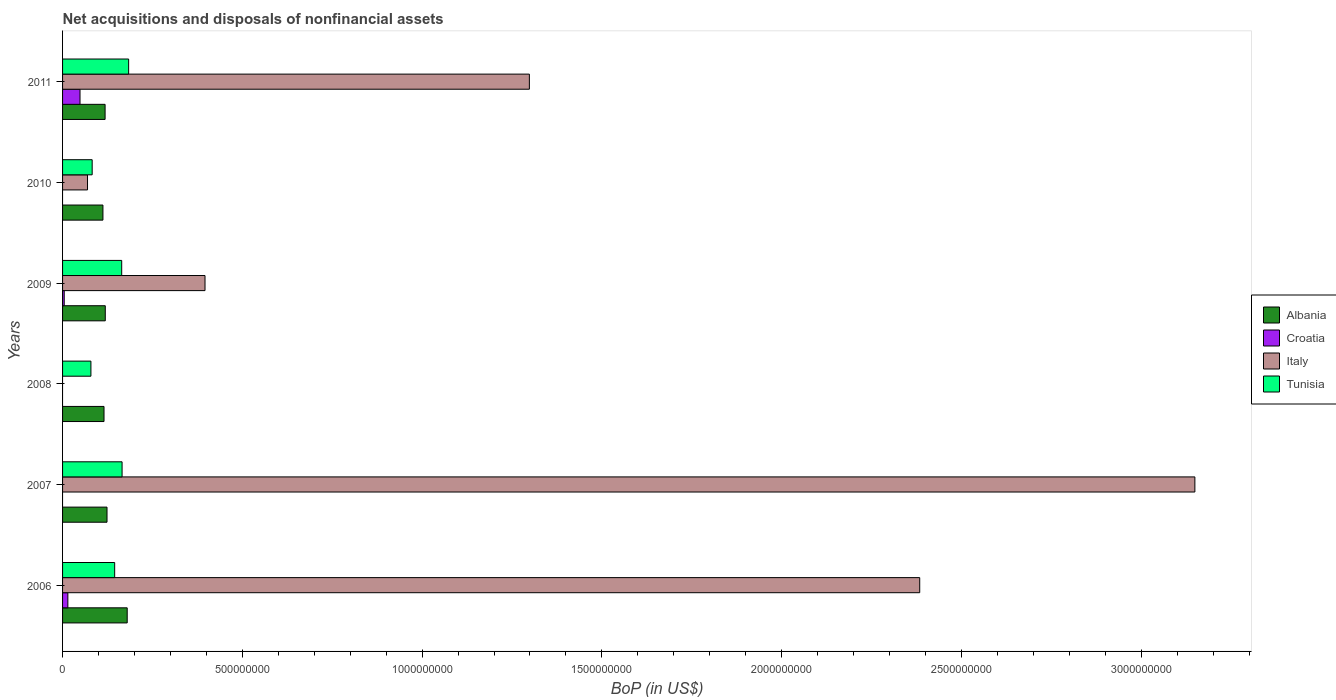How many groups of bars are there?
Provide a short and direct response. 6. How many bars are there on the 1st tick from the bottom?
Offer a terse response. 4. What is the label of the 6th group of bars from the top?
Provide a succinct answer. 2006. What is the Balance of Payments in Albania in 2008?
Your answer should be compact. 1.15e+08. Across all years, what is the maximum Balance of Payments in Albania?
Your answer should be very brief. 1.80e+08. What is the total Balance of Payments in Tunisia in the graph?
Ensure brevity in your answer.  8.20e+08. What is the difference between the Balance of Payments in Italy in 2007 and that in 2009?
Offer a very short reply. 2.75e+09. What is the difference between the Balance of Payments in Italy in 2006 and the Balance of Payments in Albania in 2007?
Your response must be concise. 2.26e+09. What is the average Balance of Payments in Croatia per year?
Provide a succinct answer. 1.13e+07. In the year 2009, what is the difference between the Balance of Payments in Croatia and Balance of Payments in Albania?
Give a very brief answer. -1.14e+08. What is the ratio of the Balance of Payments in Tunisia in 2007 to that in 2010?
Your response must be concise. 2.01. Is the difference between the Balance of Payments in Croatia in 2006 and 2009 greater than the difference between the Balance of Payments in Albania in 2006 and 2009?
Ensure brevity in your answer.  No. What is the difference between the highest and the second highest Balance of Payments in Albania?
Your answer should be compact. 5.62e+07. What is the difference between the highest and the lowest Balance of Payments in Italy?
Your answer should be compact. 3.15e+09. In how many years, is the Balance of Payments in Albania greater than the average Balance of Payments in Albania taken over all years?
Ensure brevity in your answer.  1. How many bars are there?
Give a very brief answer. 20. Are all the bars in the graph horizontal?
Offer a very short reply. Yes. Are the values on the major ticks of X-axis written in scientific E-notation?
Make the answer very short. No. Does the graph contain grids?
Your answer should be very brief. No. Where does the legend appear in the graph?
Your response must be concise. Center right. How many legend labels are there?
Make the answer very short. 4. How are the legend labels stacked?
Your answer should be very brief. Vertical. What is the title of the graph?
Make the answer very short. Net acquisitions and disposals of nonfinancial assets. Does "Latvia" appear as one of the legend labels in the graph?
Keep it short and to the point. No. What is the label or title of the X-axis?
Make the answer very short. BoP (in US$). What is the BoP (in US$) in Albania in 2006?
Give a very brief answer. 1.80e+08. What is the BoP (in US$) of Croatia in 2006?
Give a very brief answer. 1.47e+07. What is the BoP (in US$) of Italy in 2006?
Your response must be concise. 2.38e+09. What is the BoP (in US$) of Tunisia in 2006?
Your answer should be very brief. 1.45e+08. What is the BoP (in US$) in Albania in 2007?
Your answer should be compact. 1.24e+08. What is the BoP (in US$) of Italy in 2007?
Your answer should be compact. 3.15e+09. What is the BoP (in US$) in Tunisia in 2007?
Offer a very short reply. 1.66e+08. What is the BoP (in US$) of Albania in 2008?
Your answer should be compact. 1.15e+08. What is the BoP (in US$) in Croatia in 2008?
Make the answer very short. 0. What is the BoP (in US$) in Tunisia in 2008?
Give a very brief answer. 7.89e+07. What is the BoP (in US$) in Albania in 2009?
Make the answer very short. 1.19e+08. What is the BoP (in US$) of Croatia in 2009?
Your answer should be very brief. 4.61e+06. What is the BoP (in US$) in Italy in 2009?
Your response must be concise. 3.96e+08. What is the BoP (in US$) of Tunisia in 2009?
Offer a very short reply. 1.64e+08. What is the BoP (in US$) of Albania in 2010?
Ensure brevity in your answer.  1.12e+08. What is the BoP (in US$) in Croatia in 2010?
Offer a terse response. 0. What is the BoP (in US$) in Italy in 2010?
Ensure brevity in your answer.  6.94e+07. What is the BoP (in US$) in Tunisia in 2010?
Ensure brevity in your answer.  8.24e+07. What is the BoP (in US$) of Albania in 2011?
Your answer should be compact. 1.18e+08. What is the BoP (in US$) in Croatia in 2011?
Your response must be concise. 4.85e+07. What is the BoP (in US$) in Italy in 2011?
Make the answer very short. 1.30e+09. What is the BoP (in US$) of Tunisia in 2011?
Offer a terse response. 1.84e+08. Across all years, what is the maximum BoP (in US$) of Albania?
Provide a succinct answer. 1.80e+08. Across all years, what is the maximum BoP (in US$) of Croatia?
Give a very brief answer. 4.85e+07. Across all years, what is the maximum BoP (in US$) in Italy?
Provide a succinct answer. 3.15e+09. Across all years, what is the maximum BoP (in US$) in Tunisia?
Ensure brevity in your answer.  1.84e+08. Across all years, what is the minimum BoP (in US$) in Albania?
Provide a short and direct response. 1.12e+08. Across all years, what is the minimum BoP (in US$) in Croatia?
Give a very brief answer. 0. Across all years, what is the minimum BoP (in US$) in Italy?
Make the answer very short. 0. Across all years, what is the minimum BoP (in US$) in Tunisia?
Your response must be concise. 7.89e+07. What is the total BoP (in US$) in Albania in the graph?
Provide a short and direct response. 7.68e+08. What is the total BoP (in US$) of Croatia in the graph?
Your answer should be compact. 6.79e+07. What is the total BoP (in US$) in Italy in the graph?
Give a very brief answer. 7.30e+09. What is the total BoP (in US$) of Tunisia in the graph?
Keep it short and to the point. 8.20e+08. What is the difference between the BoP (in US$) of Albania in 2006 and that in 2007?
Offer a terse response. 5.62e+07. What is the difference between the BoP (in US$) of Italy in 2006 and that in 2007?
Ensure brevity in your answer.  -7.65e+08. What is the difference between the BoP (in US$) of Tunisia in 2006 and that in 2007?
Your response must be concise. -2.06e+07. What is the difference between the BoP (in US$) in Albania in 2006 and that in 2008?
Your answer should be compact. 6.45e+07. What is the difference between the BoP (in US$) in Tunisia in 2006 and that in 2008?
Provide a succinct answer. 6.60e+07. What is the difference between the BoP (in US$) of Albania in 2006 and that in 2009?
Make the answer very short. 6.10e+07. What is the difference between the BoP (in US$) in Croatia in 2006 and that in 2009?
Your answer should be compact. 1.01e+07. What is the difference between the BoP (in US$) in Italy in 2006 and that in 2009?
Your answer should be compact. 1.99e+09. What is the difference between the BoP (in US$) in Tunisia in 2006 and that in 2009?
Offer a terse response. -1.96e+07. What is the difference between the BoP (in US$) of Albania in 2006 and that in 2010?
Provide a short and direct response. 6.75e+07. What is the difference between the BoP (in US$) in Italy in 2006 and that in 2010?
Make the answer very short. 2.31e+09. What is the difference between the BoP (in US$) of Tunisia in 2006 and that in 2010?
Your answer should be very brief. 6.26e+07. What is the difference between the BoP (in US$) in Albania in 2006 and that in 2011?
Offer a terse response. 6.15e+07. What is the difference between the BoP (in US$) of Croatia in 2006 and that in 2011?
Provide a short and direct response. -3.38e+07. What is the difference between the BoP (in US$) in Italy in 2006 and that in 2011?
Make the answer very short. 1.09e+09. What is the difference between the BoP (in US$) of Tunisia in 2006 and that in 2011?
Provide a short and direct response. -3.88e+07. What is the difference between the BoP (in US$) in Albania in 2007 and that in 2008?
Provide a succinct answer. 8.34e+06. What is the difference between the BoP (in US$) in Tunisia in 2007 and that in 2008?
Give a very brief answer. 8.66e+07. What is the difference between the BoP (in US$) of Albania in 2007 and that in 2009?
Your response must be concise. 4.84e+06. What is the difference between the BoP (in US$) of Italy in 2007 and that in 2009?
Give a very brief answer. 2.75e+09. What is the difference between the BoP (in US$) of Tunisia in 2007 and that in 2009?
Provide a succinct answer. 1.04e+06. What is the difference between the BoP (in US$) of Albania in 2007 and that in 2010?
Keep it short and to the point. 1.14e+07. What is the difference between the BoP (in US$) in Italy in 2007 and that in 2010?
Your answer should be very brief. 3.08e+09. What is the difference between the BoP (in US$) in Tunisia in 2007 and that in 2010?
Give a very brief answer. 8.32e+07. What is the difference between the BoP (in US$) of Albania in 2007 and that in 2011?
Make the answer very short. 5.35e+06. What is the difference between the BoP (in US$) of Italy in 2007 and that in 2011?
Give a very brief answer. 1.85e+09. What is the difference between the BoP (in US$) of Tunisia in 2007 and that in 2011?
Keep it short and to the point. -1.82e+07. What is the difference between the BoP (in US$) in Albania in 2008 and that in 2009?
Give a very brief answer. -3.50e+06. What is the difference between the BoP (in US$) of Tunisia in 2008 and that in 2009?
Make the answer very short. -8.56e+07. What is the difference between the BoP (in US$) in Albania in 2008 and that in 2010?
Give a very brief answer. 3.03e+06. What is the difference between the BoP (in US$) of Tunisia in 2008 and that in 2010?
Provide a succinct answer. -3.48e+06. What is the difference between the BoP (in US$) of Albania in 2008 and that in 2011?
Offer a terse response. -2.99e+06. What is the difference between the BoP (in US$) in Tunisia in 2008 and that in 2011?
Offer a terse response. -1.05e+08. What is the difference between the BoP (in US$) in Albania in 2009 and that in 2010?
Offer a very short reply. 6.53e+06. What is the difference between the BoP (in US$) of Italy in 2009 and that in 2010?
Provide a succinct answer. 3.27e+08. What is the difference between the BoP (in US$) in Tunisia in 2009 and that in 2010?
Offer a very short reply. 8.21e+07. What is the difference between the BoP (in US$) of Albania in 2009 and that in 2011?
Give a very brief answer. 5.13e+05. What is the difference between the BoP (in US$) in Croatia in 2009 and that in 2011?
Your answer should be compact. -4.39e+07. What is the difference between the BoP (in US$) of Italy in 2009 and that in 2011?
Offer a terse response. -9.02e+08. What is the difference between the BoP (in US$) of Tunisia in 2009 and that in 2011?
Provide a succinct answer. -1.93e+07. What is the difference between the BoP (in US$) in Albania in 2010 and that in 2011?
Provide a succinct answer. -6.02e+06. What is the difference between the BoP (in US$) in Italy in 2010 and that in 2011?
Your answer should be very brief. -1.23e+09. What is the difference between the BoP (in US$) in Tunisia in 2010 and that in 2011?
Make the answer very short. -1.01e+08. What is the difference between the BoP (in US$) in Albania in 2006 and the BoP (in US$) in Italy in 2007?
Keep it short and to the point. -2.97e+09. What is the difference between the BoP (in US$) of Albania in 2006 and the BoP (in US$) of Tunisia in 2007?
Make the answer very short. 1.43e+07. What is the difference between the BoP (in US$) of Croatia in 2006 and the BoP (in US$) of Italy in 2007?
Provide a short and direct response. -3.13e+09. What is the difference between the BoP (in US$) in Croatia in 2006 and the BoP (in US$) in Tunisia in 2007?
Ensure brevity in your answer.  -1.51e+08. What is the difference between the BoP (in US$) in Italy in 2006 and the BoP (in US$) in Tunisia in 2007?
Provide a succinct answer. 2.22e+09. What is the difference between the BoP (in US$) in Albania in 2006 and the BoP (in US$) in Tunisia in 2008?
Give a very brief answer. 1.01e+08. What is the difference between the BoP (in US$) of Croatia in 2006 and the BoP (in US$) of Tunisia in 2008?
Give a very brief answer. -6.42e+07. What is the difference between the BoP (in US$) of Italy in 2006 and the BoP (in US$) of Tunisia in 2008?
Offer a terse response. 2.31e+09. What is the difference between the BoP (in US$) in Albania in 2006 and the BoP (in US$) in Croatia in 2009?
Your answer should be very brief. 1.75e+08. What is the difference between the BoP (in US$) of Albania in 2006 and the BoP (in US$) of Italy in 2009?
Provide a succinct answer. -2.16e+08. What is the difference between the BoP (in US$) of Albania in 2006 and the BoP (in US$) of Tunisia in 2009?
Your answer should be compact. 1.53e+07. What is the difference between the BoP (in US$) of Croatia in 2006 and the BoP (in US$) of Italy in 2009?
Offer a very short reply. -3.81e+08. What is the difference between the BoP (in US$) in Croatia in 2006 and the BoP (in US$) in Tunisia in 2009?
Offer a terse response. -1.50e+08. What is the difference between the BoP (in US$) in Italy in 2006 and the BoP (in US$) in Tunisia in 2009?
Provide a succinct answer. 2.22e+09. What is the difference between the BoP (in US$) in Albania in 2006 and the BoP (in US$) in Italy in 2010?
Your response must be concise. 1.10e+08. What is the difference between the BoP (in US$) of Albania in 2006 and the BoP (in US$) of Tunisia in 2010?
Ensure brevity in your answer.  9.74e+07. What is the difference between the BoP (in US$) in Croatia in 2006 and the BoP (in US$) in Italy in 2010?
Offer a very short reply. -5.46e+07. What is the difference between the BoP (in US$) of Croatia in 2006 and the BoP (in US$) of Tunisia in 2010?
Keep it short and to the point. -6.76e+07. What is the difference between the BoP (in US$) in Italy in 2006 and the BoP (in US$) in Tunisia in 2010?
Offer a very short reply. 2.30e+09. What is the difference between the BoP (in US$) in Albania in 2006 and the BoP (in US$) in Croatia in 2011?
Offer a terse response. 1.31e+08. What is the difference between the BoP (in US$) of Albania in 2006 and the BoP (in US$) of Italy in 2011?
Provide a succinct answer. -1.12e+09. What is the difference between the BoP (in US$) of Albania in 2006 and the BoP (in US$) of Tunisia in 2011?
Your response must be concise. -3.97e+06. What is the difference between the BoP (in US$) of Croatia in 2006 and the BoP (in US$) of Italy in 2011?
Offer a terse response. -1.28e+09. What is the difference between the BoP (in US$) in Croatia in 2006 and the BoP (in US$) in Tunisia in 2011?
Give a very brief answer. -1.69e+08. What is the difference between the BoP (in US$) in Italy in 2006 and the BoP (in US$) in Tunisia in 2011?
Your response must be concise. 2.20e+09. What is the difference between the BoP (in US$) in Albania in 2007 and the BoP (in US$) in Tunisia in 2008?
Ensure brevity in your answer.  4.48e+07. What is the difference between the BoP (in US$) in Italy in 2007 and the BoP (in US$) in Tunisia in 2008?
Ensure brevity in your answer.  3.07e+09. What is the difference between the BoP (in US$) in Albania in 2007 and the BoP (in US$) in Croatia in 2009?
Offer a very short reply. 1.19e+08. What is the difference between the BoP (in US$) of Albania in 2007 and the BoP (in US$) of Italy in 2009?
Ensure brevity in your answer.  -2.73e+08. What is the difference between the BoP (in US$) of Albania in 2007 and the BoP (in US$) of Tunisia in 2009?
Your answer should be compact. -4.08e+07. What is the difference between the BoP (in US$) in Italy in 2007 and the BoP (in US$) in Tunisia in 2009?
Keep it short and to the point. 2.98e+09. What is the difference between the BoP (in US$) of Albania in 2007 and the BoP (in US$) of Italy in 2010?
Provide a succinct answer. 5.43e+07. What is the difference between the BoP (in US$) in Albania in 2007 and the BoP (in US$) in Tunisia in 2010?
Keep it short and to the point. 4.13e+07. What is the difference between the BoP (in US$) in Italy in 2007 and the BoP (in US$) in Tunisia in 2010?
Your answer should be very brief. 3.07e+09. What is the difference between the BoP (in US$) in Albania in 2007 and the BoP (in US$) in Croatia in 2011?
Your answer should be compact. 7.51e+07. What is the difference between the BoP (in US$) of Albania in 2007 and the BoP (in US$) of Italy in 2011?
Make the answer very short. -1.17e+09. What is the difference between the BoP (in US$) of Albania in 2007 and the BoP (in US$) of Tunisia in 2011?
Your answer should be very brief. -6.01e+07. What is the difference between the BoP (in US$) in Italy in 2007 and the BoP (in US$) in Tunisia in 2011?
Give a very brief answer. 2.97e+09. What is the difference between the BoP (in US$) of Albania in 2008 and the BoP (in US$) of Croatia in 2009?
Your response must be concise. 1.11e+08. What is the difference between the BoP (in US$) of Albania in 2008 and the BoP (in US$) of Italy in 2009?
Your answer should be compact. -2.81e+08. What is the difference between the BoP (in US$) in Albania in 2008 and the BoP (in US$) in Tunisia in 2009?
Offer a terse response. -4.92e+07. What is the difference between the BoP (in US$) in Albania in 2008 and the BoP (in US$) in Italy in 2010?
Your answer should be very brief. 4.59e+07. What is the difference between the BoP (in US$) in Albania in 2008 and the BoP (in US$) in Tunisia in 2010?
Your response must be concise. 3.29e+07. What is the difference between the BoP (in US$) of Albania in 2008 and the BoP (in US$) of Croatia in 2011?
Your response must be concise. 6.68e+07. What is the difference between the BoP (in US$) in Albania in 2008 and the BoP (in US$) in Italy in 2011?
Offer a very short reply. -1.18e+09. What is the difference between the BoP (in US$) in Albania in 2008 and the BoP (in US$) in Tunisia in 2011?
Provide a succinct answer. -6.85e+07. What is the difference between the BoP (in US$) in Albania in 2009 and the BoP (in US$) in Italy in 2010?
Provide a short and direct response. 4.94e+07. What is the difference between the BoP (in US$) of Albania in 2009 and the BoP (in US$) of Tunisia in 2010?
Provide a short and direct response. 3.64e+07. What is the difference between the BoP (in US$) in Croatia in 2009 and the BoP (in US$) in Italy in 2010?
Provide a short and direct response. -6.48e+07. What is the difference between the BoP (in US$) in Croatia in 2009 and the BoP (in US$) in Tunisia in 2010?
Offer a very short reply. -7.78e+07. What is the difference between the BoP (in US$) in Italy in 2009 and the BoP (in US$) in Tunisia in 2010?
Offer a very short reply. 3.14e+08. What is the difference between the BoP (in US$) in Albania in 2009 and the BoP (in US$) in Croatia in 2011?
Your answer should be compact. 7.03e+07. What is the difference between the BoP (in US$) of Albania in 2009 and the BoP (in US$) of Italy in 2011?
Provide a succinct answer. -1.18e+09. What is the difference between the BoP (in US$) of Albania in 2009 and the BoP (in US$) of Tunisia in 2011?
Offer a terse response. -6.50e+07. What is the difference between the BoP (in US$) of Croatia in 2009 and the BoP (in US$) of Italy in 2011?
Your answer should be compact. -1.29e+09. What is the difference between the BoP (in US$) in Croatia in 2009 and the BoP (in US$) in Tunisia in 2011?
Ensure brevity in your answer.  -1.79e+08. What is the difference between the BoP (in US$) of Italy in 2009 and the BoP (in US$) of Tunisia in 2011?
Offer a very short reply. 2.12e+08. What is the difference between the BoP (in US$) in Albania in 2010 and the BoP (in US$) in Croatia in 2011?
Ensure brevity in your answer.  6.37e+07. What is the difference between the BoP (in US$) in Albania in 2010 and the BoP (in US$) in Italy in 2011?
Give a very brief answer. -1.19e+09. What is the difference between the BoP (in US$) of Albania in 2010 and the BoP (in US$) of Tunisia in 2011?
Offer a very short reply. -7.15e+07. What is the difference between the BoP (in US$) in Italy in 2010 and the BoP (in US$) in Tunisia in 2011?
Your response must be concise. -1.14e+08. What is the average BoP (in US$) of Albania per year?
Make the answer very short. 1.28e+08. What is the average BoP (in US$) of Croatia per year?
Your answer should be very brief. 1.13e+07. What is the average BoP (in US$) in Italy per year?
Keep it short and to the point. 1.22e+09. What is the average BoP (in US$) of Tunisia per year?
Your response must be concise. 1.37e+08. In the year 2006, what is the difference between the BoP (in US$) of Albania and BoP (in US$) of Croatia?
Your answer should be compact. 1.65e+08. In the year 2006, what is the difference between the BoP (in US$) of Albania and BoP (in US$) of Italy?
Offer a very short reply. -2.20e+09. In the year 2006, what is the difference between the BoP (in US$) of Albania and BoP (in US$) of Tunisia?
Provide a succinct answer. 3.49e+07. In the year 2006, what is the difference between the BoP (in US$) in Croatia and BoP (in US$) in Italy?
Provide a short and direct response. -2.37e+09. In the year 2006, what is the difference between the BoP (in US$) in Croatia and BoP (in US$) in Tunisia?
Make the answer very short. -1.30e+08. In the year 2006, what is the difference between the BoP (in US$) of Italy and BoP (in US$) of Tunisia?
Keep it short and to the point. 2.24e+09. In the year 2007, what is the difference between the BoP (in US$) in Albania and BoP (in US$) in Italy?
Offer a terse response. -3.03e+09. In the year 2007, what is the difference between the BoP (in US$) in Albania and BoP (in US$) in Tunisia?
Offer a terse response. -4.19e+07. In the year 2007, what is the difference between the BoP (in US$) of Italy and BoP (in US$) of Tunisia?
Offer a very short reply. 2.98e+09. In the year 2008, what is the difference between the BoP (in US$) in Albania and BoP (in US$) in Tunisia?
Offer a very short reply. 3.64e+07. In the year 2009, what is the difference between the BoP (in US$) in Albania and BoP (in US$) in Croatia?
Your answer should be very brief. 1.14e+08. In the year 2009, what is the difference between the BoP (in US$) of Albania and BoP (in US$) of Italy?
Give a very brief answer. -2.77e+08. In the year 2009, what is the difference between the BoP (in US$) of Albania and BoP (in US$) of Tunisia?
Offer a terse response. -4.57e+07. In the year 2009, what is the difference between the BoP (in US$) in Croatia and BoP (in US$) in Italy?
Ensure brevity in your answer.  -3.92e+08. In the year 2009, what is the difference between the BoP (in US$) of Croatia and BoP (in US$) of Tunisia?
Give a very brief answer. -1.60e+08. In the year 2009, what is the difference between the BoP (in US$) of Italy and BoP (in US$) of Tunisia?
Provide a succinct answer. 2.32e+08. In the year 2010, what is the difference between the BoP (in US$) in Albania and BoP (in US$) in Italy?
Your answer should be very brief. 4.29e+07. In the year 2010, what is the difference between the BoP (in US$) of Albania and BoP (in US$) of Tunisia?
Offer a terse response. 2.99e+07. In the year 2010, what is the difference between the BoP (in US$) of Italy and BoP (in US$) of Tunisia?
Your response must be concise. -1.30e+07. In the year 2011, what is the difference between the BoP (in US$) of Albania and BoP (in US$) of Croatia?
Provide a short and direct response. 6.98e+07. In the year 2011, what is the difference between the BoP (in US$) in Albania and BoP (in US$) in Italy?
Provide a succinct answer. -1.18e+09. In the year 2011, what is the difference between the BoP (in US$) of Albania and BoP (in US$) of Tunisia?
Give a very brief answer. -6.55e+07. In the year 2011, what is the difference between the BoP (in US$) in Croatia and BoP (in US$) in Italy?
Keep it short and to the point. -1.25e+09. In the year 2011, what is the difference between the BoP (in US$) in Croatia and BoP (in US$) in Tunisia?
Your response must be concise. -1.35e+08. In the year 2011, what is the difference between the BoP (in US$) of Italy and BoP (in US$) of Tunisia?
Provide a succinct answer. 1.11e+09. What is the ratio of the BoP (in US$) of Albania in 2006 to that in 2007?
Offer a very short reply. 1.45. What is the ratio of the BoP (in US$) in Italy in 2006 to that in 2007?
Ensure brevity in your answer.  0.76. What is the ratio of the BoP (in US$) of Tunisia in 2006 to that in 2007?
Provide a succinct answer. 0.88. What is the ratio of the BoP (in US$) of Albania in 2006 to that in 2008?
Your response must be concise. 1.56. What is the ratio of the BoP (in US$) of Tunisia in 2006 to that in 2008?
Your response must be concise. 1.84. What is the ratio of the BoP (in US$) of Albania in 2006 to that in 2009?
Provide a succinct answer. 1.51. What is the ratio of the BoP (in US$) in Croatia in 2006 to that in 2009?
Provide a succinct answer. 3.2. What is the ratio of the BoP (in US$) of Italy in 2006 to that in 2009?
Offer a terse response. 6.02. What is the ratio of the BoP (in US$) of Tunisia in 2006 to that in 2009?
Your answer should be very brief. 0.88. What is the ratio of the BoP (in US$) of Albania in 2006 to that in 2010?
Your answer should be compact. 1.6. What is the ratio of the BoP (in US$) of Italy in 2006 to that in 2010?
Your response must be concise. 34.36. What is the ratio of the BoP (in US$) in Tunisia in 2006 to that in 2010?
Your answer should be very brief. 1.76. What is the ratio of the BoP (in US$) of Albania in 2006 to that in 2011?
Keep it short and to the point. 1.52. What is the ratio of the BoP (in US$) in Croatia in 2006 to that in 2011?
Offer a terse response. 0.3. What is the ratio of the BoP (in US$) of Italy in 2006 to that in 2011?
Give a very brief answer. 1.84. What is the ratio of the BoP (in US$) of Tunisia in 2006 to that in 2011?
Your response must be concise. 0.79. What is the ratio of the BoP (in US$) of Albania in 2007 to that in 2008?
Your response must be concise. 1.07. What is the ratio of the BoP (in US$) in Tunisia in 2007 to that in 2008?
Offer a very short reply. 2.1. What is the ratio of the BoP (in US$) in Albania in 2007 to that in 2009?
Ensure brevity in your answer.  1.04. What is the ratio of the BoP (in US$) of Italy in 2007 to that in 2009?
Offer a very short reply. 7.95. What is the ratio of the BoP (in US$) of Tunisia in 2007 to that in 2009?
Your response must be concise. 1.01. What is the ratio of the BoP (in US$) of Albania in 2007 to that in 2010?
Make the answer very short. 1.1. What is the ratio of the BoP (in US$) in Italy in 2007 to that in 2010?
Keep it short and to the point. 45.4. What is the ratio of the BoP (in US$) in Tunisia in 2007 to that in 2010?
Offer a very short reply. 2.01. What is the ratio of the BoP (in US$) of Albania in 2007 to that in 2011?
Provide a short and direct response. 1.05. What is the ratio of the BoP (in US$) in Italy in 2007 to that in 2011?
Keep it short and to the point. 2.43. What is the ratio of the BoP (in US$) of Tunisia in 2007 to that in 2011?
Make the answer very short. 0.9. What is the ratio of the BoP (in US$) in Albania in 2008 to that in 2009?
Make the answer very short. 0.97. What is the ratio of the BoP (in US$) in Tunisia in 2008 to that in 2009?
Offer a terse response. 0.48. What is the ratio of the BoP (in US$) of Tunisia in 2008 to that in 2010?
Make the answer very short. 0.96. What is the ratio of the BoP (in US$) of Albania in 2008 to that in 2011?
Your answer should be compact. 0.97. What is the ratio of the BoP (in US$) in Tunisia in 2008 to that in 2011?
Provide a succinct answer. 0.43. What is the ratio of the BoP (in US$) in Albania in 2009 to that in 2010?
Offer a very short reply. 1.06. What is the ratio of the BoP (in US$) of Italy in 2009 to that in 2010?
Offer a very short reply. 5.71. What is the ratio of the BoP (in US$) in Tunisia in 2009 to that in 2010?
Your response must be concise. 2. What is the ratio of the BoP (in US$) of Albania in 2009 to that in 2011?
Your answer should be compact. 1. What is the ratio of the BoP (in US$) in Croatia in 2009 to that in 2011?
Offer a terse response. 0.1. What is the ratio of the BoP (in US$) of Italy in 2009 to that in 2011?
Your answer should be very brief. 0.31. What is the ratio of the BoP (in US$) of Tunisia in 2009 to that in 2011?
Your response must be concise. 0.9. What is the ratio of the BoP (in US$) in Albania in 2010 to that in 2011?
Make the answer very short. 0.95. What is the ratio of the BoP (in US$) of Italy in 2010 to that in 2011?
Your answer should be very brief. 0.05. What is the ratio of the BoP (in US$) of Tunisia in 2010 to that in 2011?
Keep it short and to the point. 0.45. What is the difference between the highest and the second highest BoP (in US$) of Albania?
Keep it short and to the point. 5.62e+07. What is the difference between the highest and the second highest BoP (in US$) in Croatia?
Offer a very short reply. 3.38e+07. What is the difference between the highest and the second highest BoP (in US$) in Italy?
Your answer should be very brief. 7.65e+08. What is the difference between the highest and the second highest BoP (in US$) in Tunisia?
Provide a short and direct response. 1.82e+07. What is the difference between the highest and the lowest BoP (in US$) in Albania?
Provide a succinct answer. 6.75e+07. What is the difference between the highest and the lowest BoP (in US$) of Croatia?
Your answer should be compact. 4.85e+07. What is the difference between the highest and the lowest BoP (in US$) of Italy?
Give a very brief answer. 3.15e+09. What is the difference between the highest and the lowest BoP (in US$) in Tunisia?
Provide a succinct answer. 1.05e+08. 